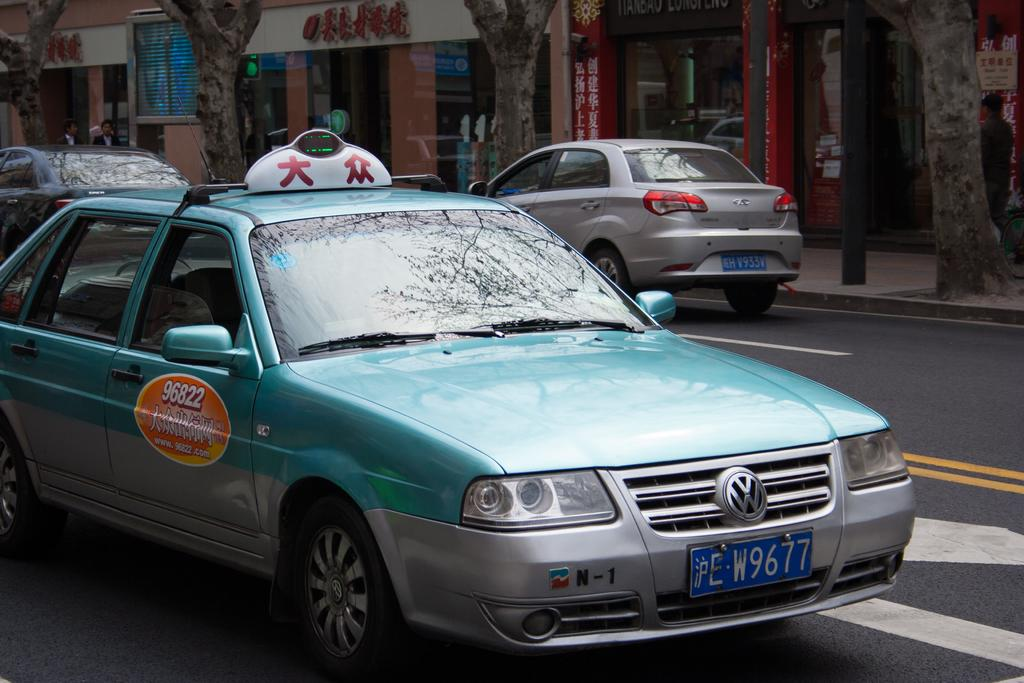<image>
Describe the image concisely. green volskvagon taxi car driving on the street 